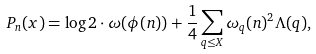<formula> <loc_0><loc_0><loc_500><loc_500>P _ { n } ( x ) = \log 2 \cdot \omega ( \phi ( n ) ) + \frac { 1 } { 4 } \sum _ { q \leq X } \omega _ { q } ( n ) ^ { 2 } \Lambda ( q ) ,</formula> 